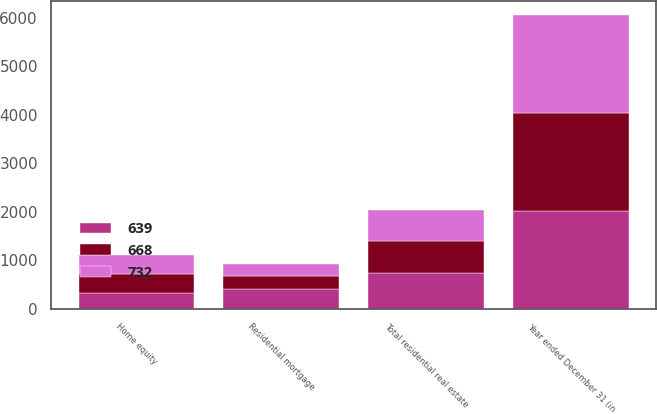Convert chart to OTSL. <chart><loc_0><loc_0><loc_500><loc_500><stacked_bar_chart><ecel><fcel>Year ended December 31 (in<fcel>Home equity<fcel>Residential mortgage<fcel>Total residential real estate<nl><fcel>732<fcel>2016<fcel>385<fcel>254<fcel>639<nl><fcel>668<fcel>2015<fcel>401<fcel>267<fcel>668<nl><fcel>639<fcel>2014<fcel>321<fcel>411<fcel>732<nl></chart> 